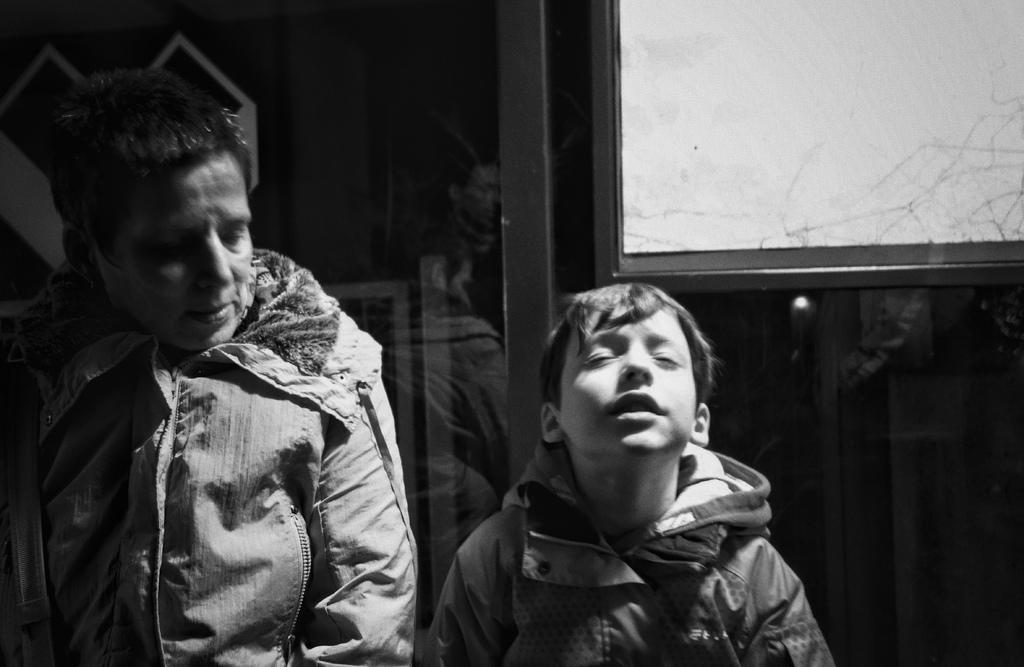What is the color scheme of the image? The image is black and white. How many people are in the image? There are two persons in the image. What can be seen behind the two persons in the image? There is a reflection of people behind the two persons. What object is visible in the image? There is a board visible in the image. What type of noise can be heard coming from the tin in the image? There is no tin present in the image, so it is not possible to determine what, if any, noise might be heard. 